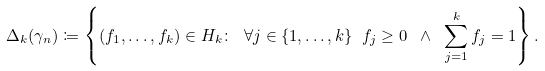<formula> <loc_0><loc_0><loc_500><loc_500>\Delta _ { k } ( \gamma _ { n } ) \coloneqq \left \{ ( f _ { 1 } , \dots , f _ { k } ) \in H _ { k } \colon \ \forall j \in \{ 1 , \dots , k \} \ f _ { j } \geq 0 \ \wedge \ \sum _ { j = 1 } ^ { k } f _ { j } = 1 \right \} .</formula> 